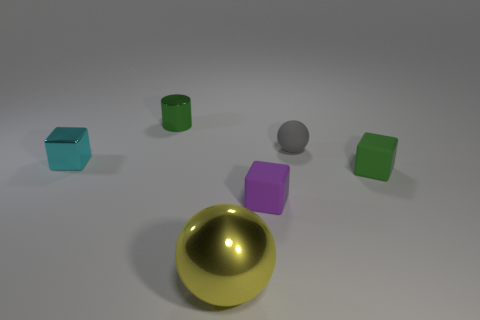Add 2 tiny green rubber cubes. How many objects exist? 8 Subtract all cylinders. How many objects are left? 5 Subtract 0 blue blocks. How many objects are left? 6 Subtract all large gray shiny blocks. Subtract all gray objects. How many objects are left? 5 Add 5 large yellow balls. How many large yellow balls are left? 6 Add 3 large gray shiny cubes. How many large gray shiny cubes exist? 3 